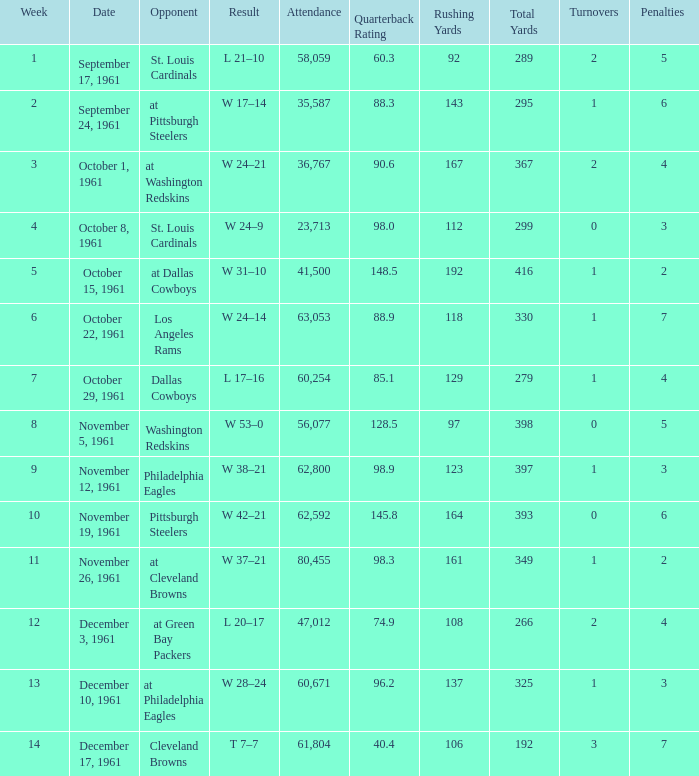Which Attendance has a Date of november 19, 1961? 62592.0. 